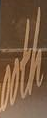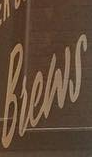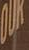What words are shown in these images in order, separated by a semicolon? ooth; Brews; OUK 